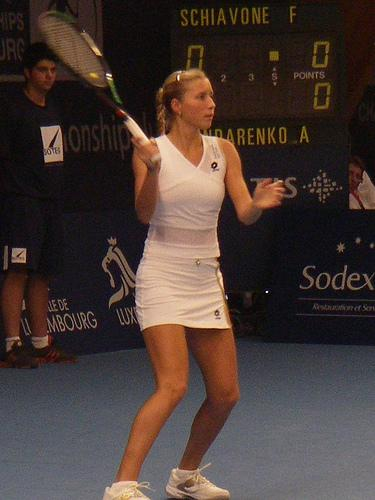Question: what is the woman holding?
Choices:
A. Cup.
B. A racket.
C. Glass.
D. Fork.
Answer with the letter. Answer: B Question: who is playing tennis?
Choices:
A. Man.
B. Instructor.
C. Child.
D. A woman.
Answer with the letter. Answer: D Question: what is the color of the woman's skirt?
Choices:
A. Purple.
B. White.
C. Black.
D. Red.
Answer with the letter. Answer: B 